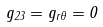<formula> <loc_0><loc_0><loc_500><loc_500>g _ { 2 3 } = g _ { r \theta } = 0</formula> 